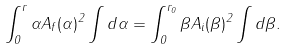Convert formula to latex. <formula><loc_0><loc_0><loc_500><loc_500>\int _ { 0 } ^ { r } \alpha A _ { f } ( \alpha ) ^ { 2 } \int d { \alpha } = \int _ { 0 } ^ { r _ { 0 } } \beta A _ { i } ( \beta ) ^ { 2 } \int d { \beta } .</formula> 